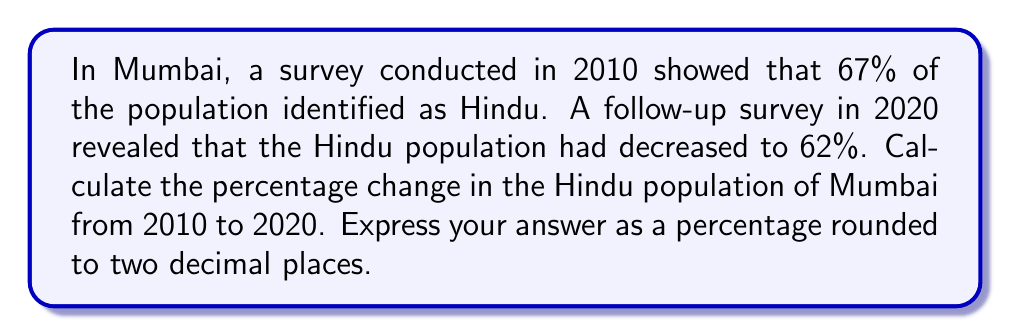Teach me how to tackle this problem. To calculate the percentage change in the Hindu population of Mumbai from 2010 to 2020, we'll use the following formula:

$$ \text{Percentage Change} = \frac{\text{New Value} - \text{Original Value}}{\text{Original Value}} \times 100\% $$

Let's substitute the values:
- Original Value (2010): 67%
- New Value (2020): 62%

$$ \text{Percentage Change} = \frac{62\% - 67\%}{67\%} \times 100\% $$

$$ = \frac{-5\%}{67\%} \times 100\% $$

$$ = -0.0746268656716418 \times 100\% $$

$$ = -7.4626865671641791\% $$

Rounding to two decimal places:

$$ = -7.46\% $$

The negative value indicates a decrease in the Hindu population percentage.
Answer: -7.46% 